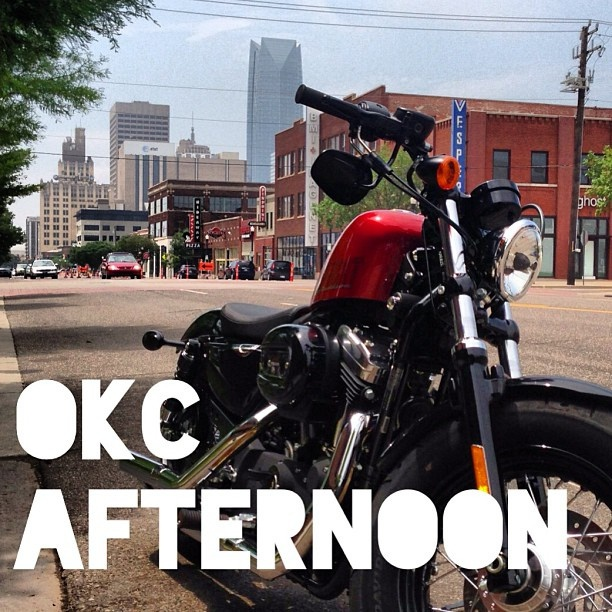Describe the objects in this image and their specific colors. I can see motorcycle in black, white, gray, and maroon tones, car in black, darkgray, lightpink, and maroon tones, car in black, gray, darkgray, and maroon tones, car in black, gray, darkgray, and maroon tones, and car in black, lightgray, darkgray, and gray tones in this image. 